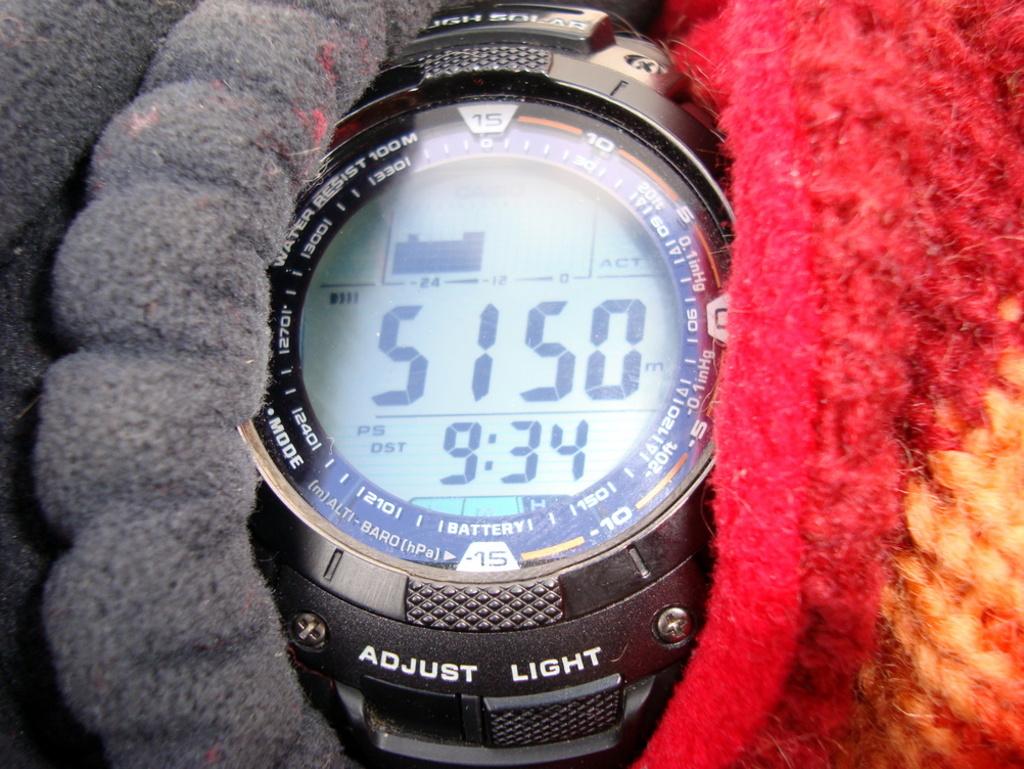What is the time of this watch?
Ensure brevity in your answer.  9:34. 